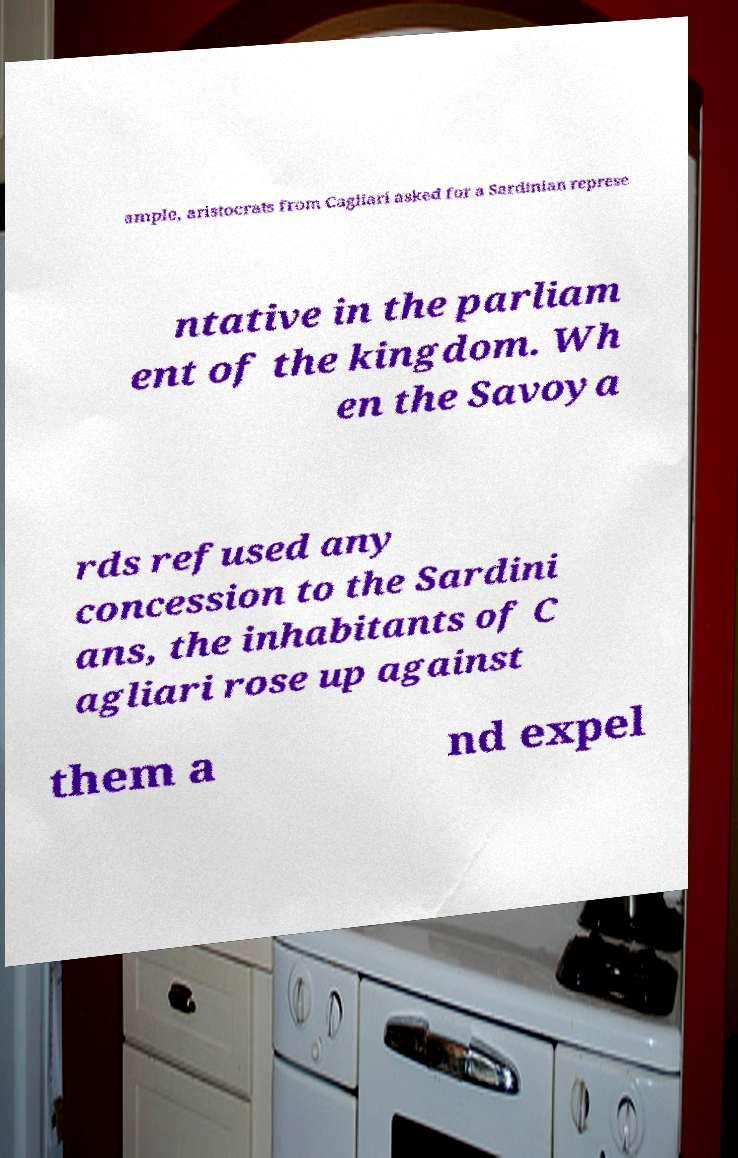Please read and relay the text visible in this image. What does it say? ample, aristocrats from Cagliari asked for a Sardinian represe ntative in the parliam ent of the kingdom. Wh en the Savoya rds refused any concession to the Sardini ans, the inhabitants of C agliari rose up against them a nd expel 